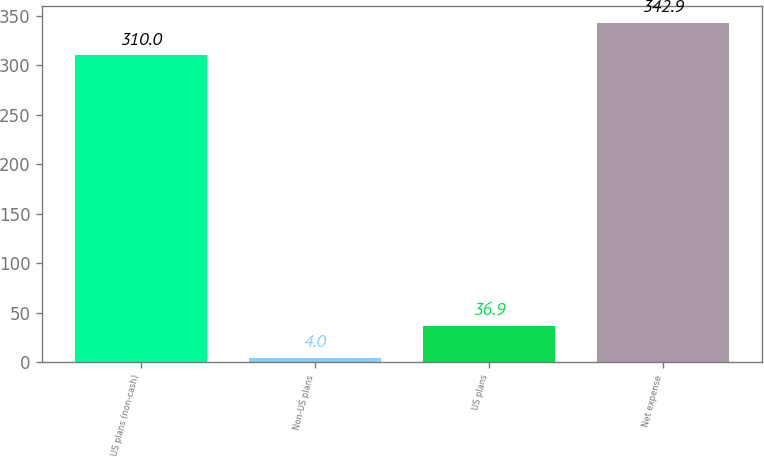<chart> <loc_0><loc_0><loc_500><loc_500><bar_chart><fcel>US plans (non-cash)<fcel>Non-US plans<fcel>US plans<fcel>Net expense<nl><fcel>310<fcel>4<fcel>36.9<fcel>342.9<nl></chart> 